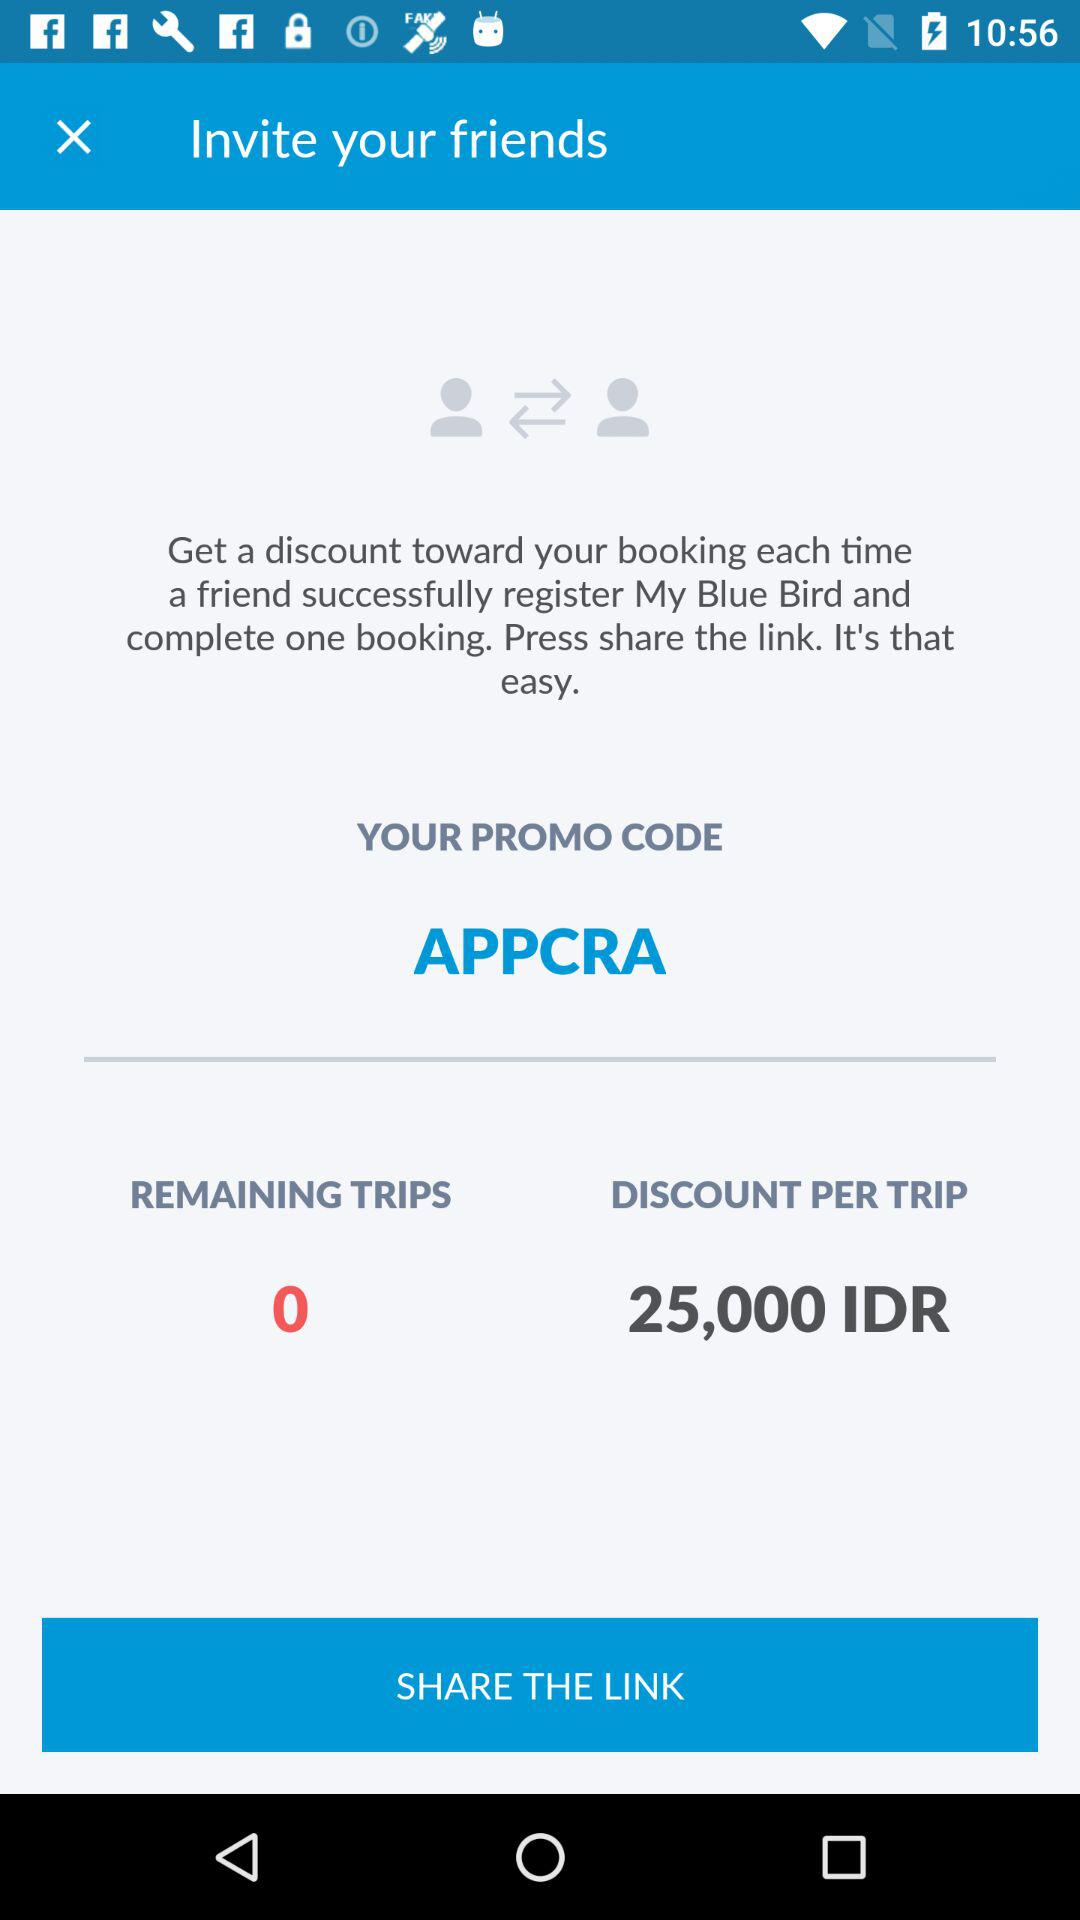What is the promo code? The promo code is APPCRA. 